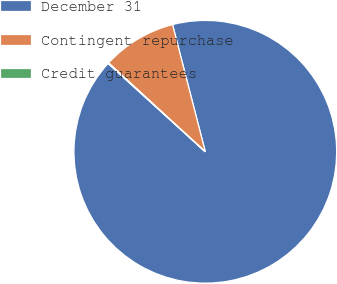Convert chart to OTSL. <chart><loc_0><loc_0><loc_500><loc_500><pie_chart><fcel>December 31<fcel>Contingent repurchase<fcel>Credit guarantees<nl><fcel>90.75%<fcel>9.16%<fcel>0.09%<nl></chart> 